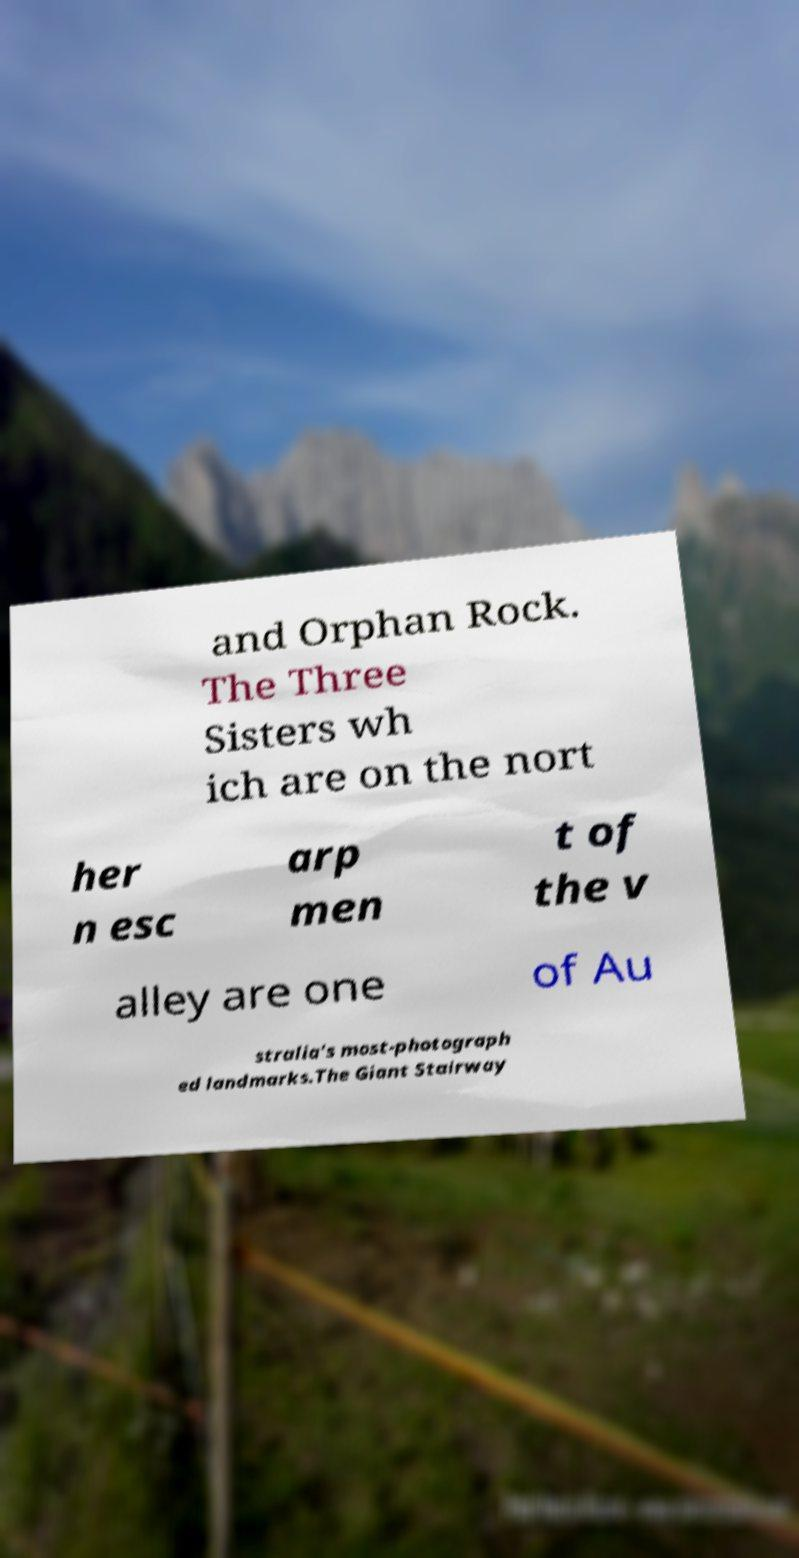There's text embedded in this image that I need extracted. Can you transcribe it verbatim? and Orphan Rock. The Three Sisters wh ich are on the nort her n esc arp men t of the v alley are one of Au stralia's most-photograph ed landmarks.The Giant Stairway 